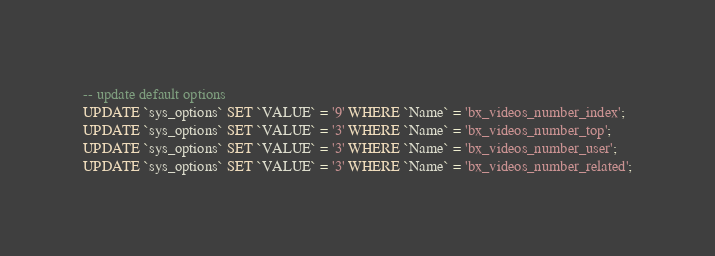<code> <loc_0><loc_0><loc_500><loc_500><_SQL_>
-- update default options
UPDATE `sys_options` SET `VALUE` = '9' WHERE `Name` = 'bx_videos_number_index';
UPDATE `sys_options` SET `VALUE` = '3' WHERE `Name` = 'bx_videos_number_top';
UPDATE `sys_options` SET `VALUE` = '3' WHERE `Name` = 'bx_videos_number_user';
UPDATE `sys_options` SET `VALUE` = '3' WHERE `Name` = 'bx_videos_number_related';</code> 